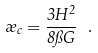Convert formula to latex. <formula><loc_0><loc_0><loc_500><loc_500>\rho _ { c } = \frac { 3 H ^ { 2 } } { 8 \pi G } \ .</formula> 